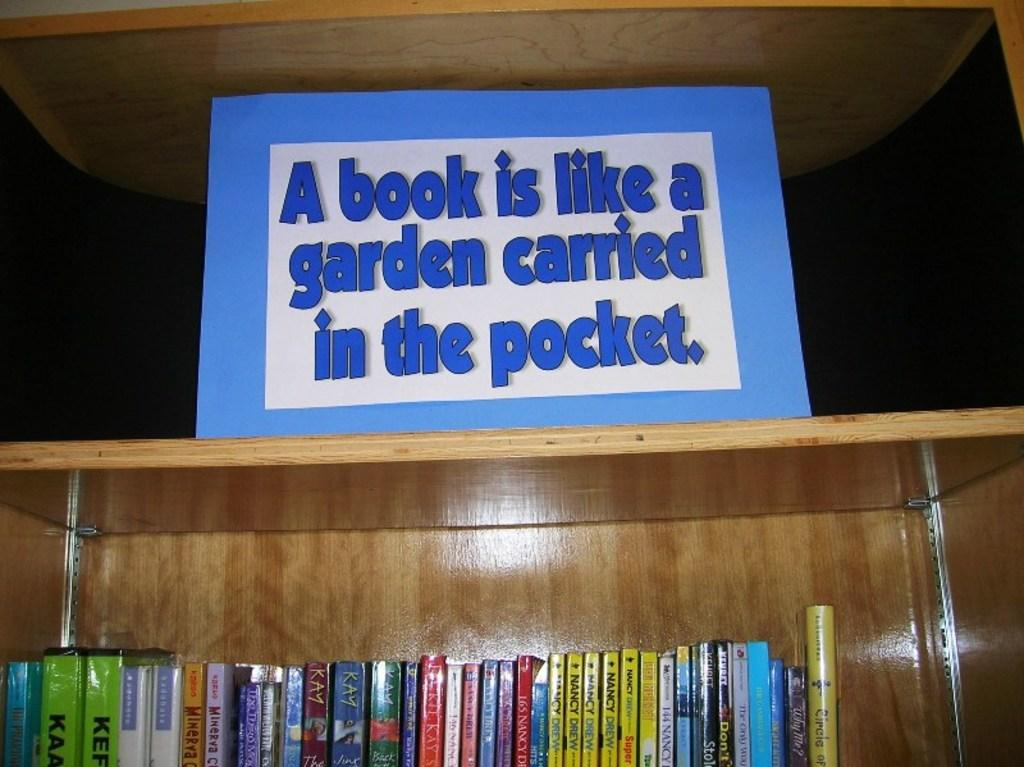Provide a one-sentence caption for the provided image. A book shelf with a blue sign on top that says A book is like a garden carried in the pocket. 